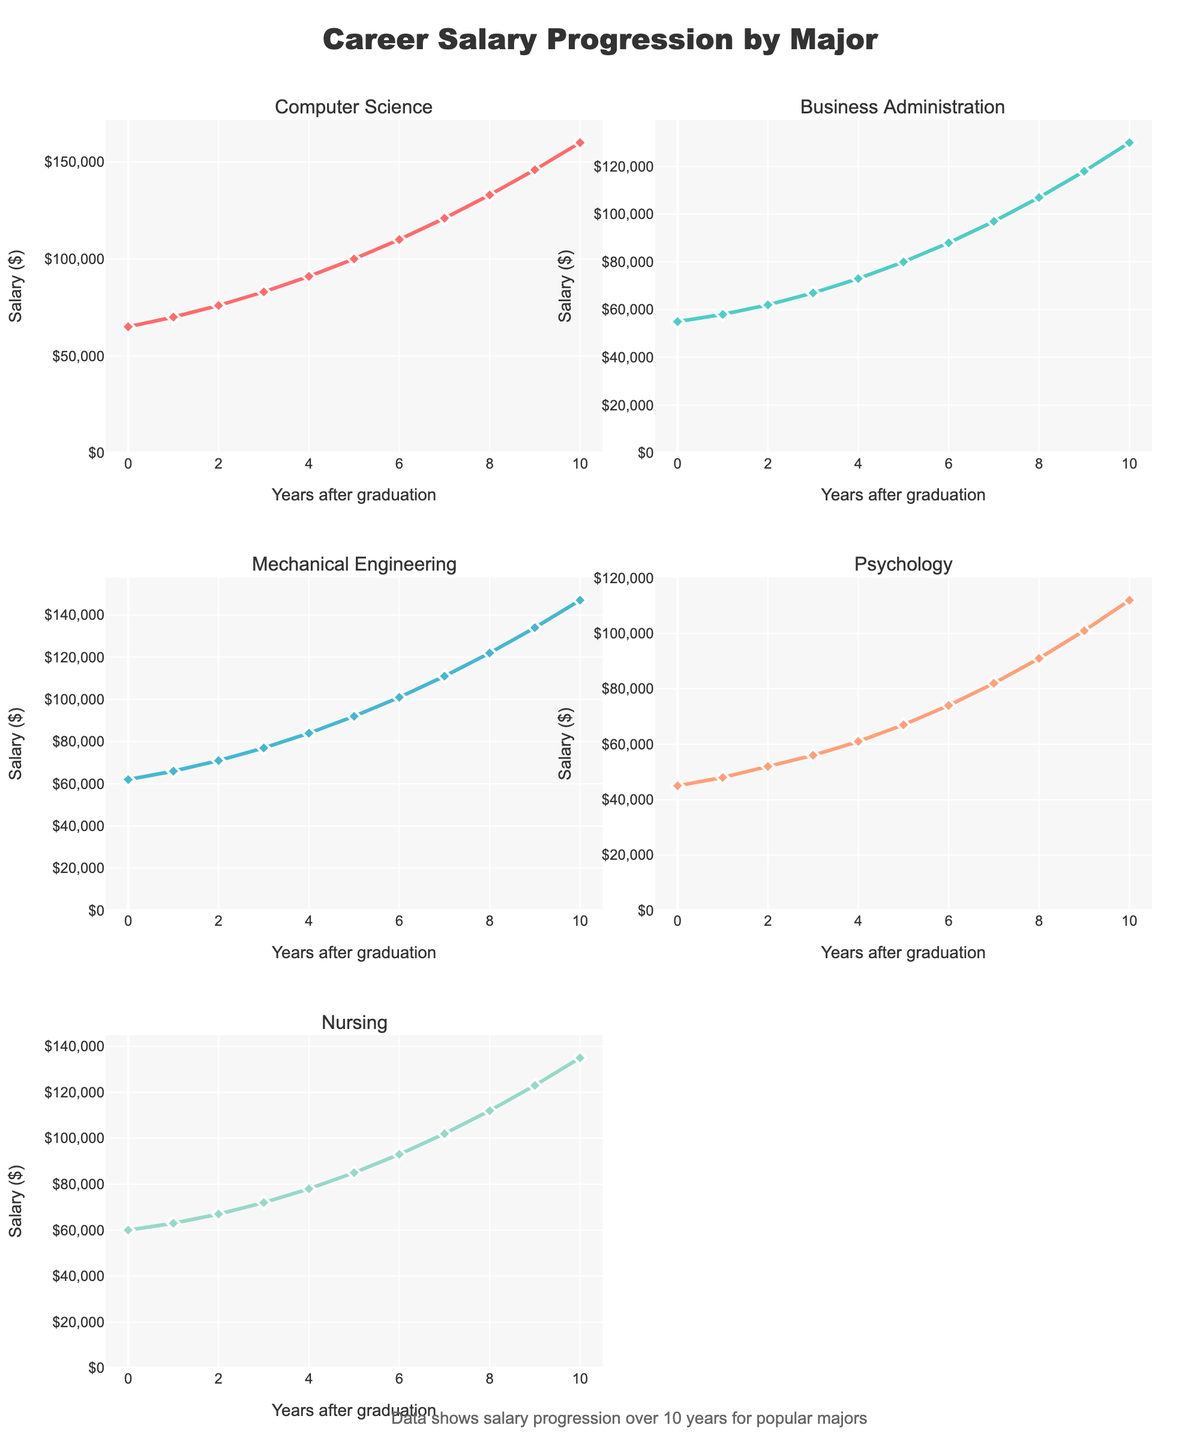What is the title of the plot? The title is displayed at the top center of the plot, and it reads "Career Salary Progression by Major".
Answer: Career Salary Progression by Major How many subplots are there, and how are they arranged? There are 5 subplots arranged in a grid with 3 rows and 2 columns. The subplots represent different majors: "Computer Science", "Business Administration", "Mechanical Engineering", "Psychology", and "Nursing".
Answer: 5 subplots in 3 rows and 2 columns Which major shows the highest salary increase from 0 to 10 years post-graduation? By examining all the final data points in each subplot, "Computer Science" starts at $65,000 and ends at $160,000, which is the highest increase of $95,000.
Answer: Computer Science What is the average salary for Mechanical Engineering at 5 and 10 years post-graduation? Add the salary values for Mechanical Engineering at 5 years ($92,000) and 10 years ($147,000), then divide by 2. (92,000 + 147,000) / 2 = 119,500
Answer: $119,500 How does the salary progression for Nursing compare to Psychology at the 7-year mark? At the 7-year mark, the salary for Nursing is $102,000 and for Psychology is $82,000. Nursing has a higher salary than Psychology by $20,000.
Answer: Nursing is $20,000 higher Which major has the smallest increase in salary 3 years after graduation when compared to 0 years? Calculate the difference between year 3 and year 0 for each major. The smallest increase is found for Psychology: $56,000 - $45,000 = $11,000.
Answer: Psychology What is the salary difference between Business Administration and Mechanical Engineering at the 8-year mark? At year 8, Business Administration has a salary of $107,000 and Mechanical Engineering has a salary of $122,000. The difference is $122,000 - $107,000 = $15,000.
Answer: $15,000 Which major has a consistent upward trend in salary over the 10 years? All majors show an upward trend, but "Computer Science" and "Mechanical Engineering" are the most consistent with no dips or plateaus.
Answer: Computer Science and Mechanical Engineering What is the total salary increase for Nursing from 0 to 10 years post-graduation? The total increase is the difference between the salary at year 10 ($135,000) and at year 0 ($60,000). $135,000 - $60,000 = $75,000.
Answer: $75,000 What year shows the largest jump in salary for Business Administration, and what is that increase? By examining changes in salary year over year, the largest jump for Business Administration is between years 9 and 10: $130,000 - $118,000 = $12,000.
Answer: Between years 9 and 10 with $12,000 increase 